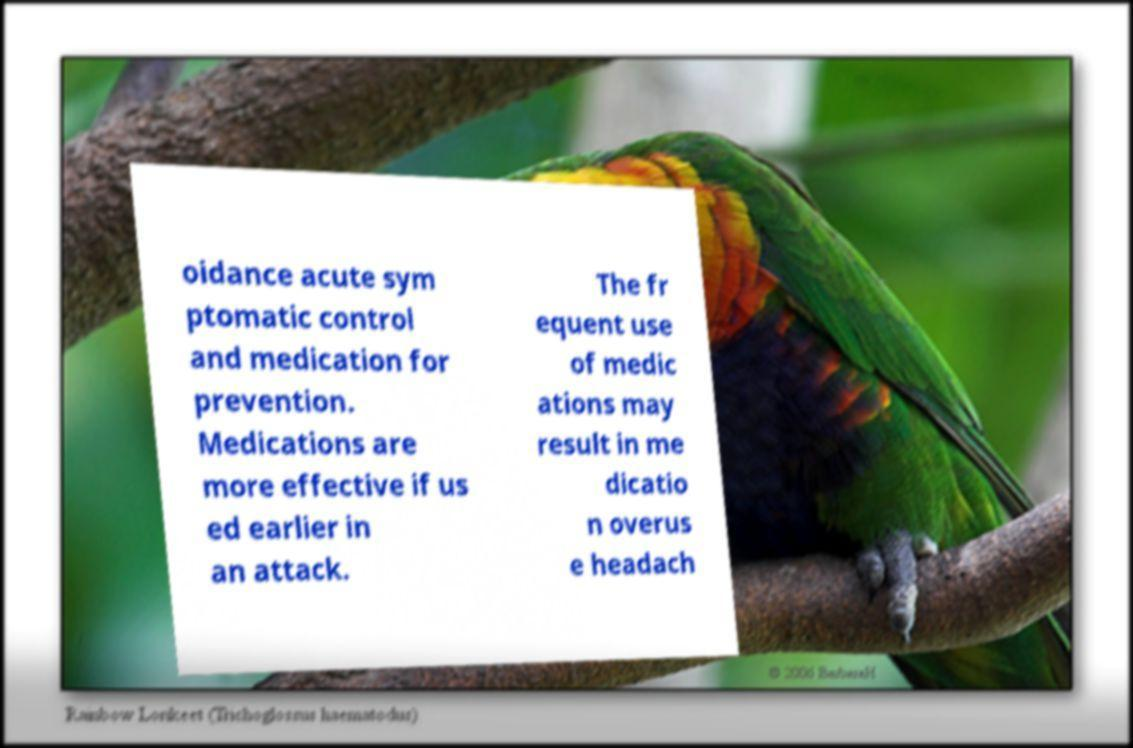What messages or text are displayed in this image? I need them in a readable, typed format. oidance acute sym ptomatic control and medication for prevention. Medications are more effective if us ed earlier in an attack. The fr equent use of medic ations may result in me dicatio n overus e headach 